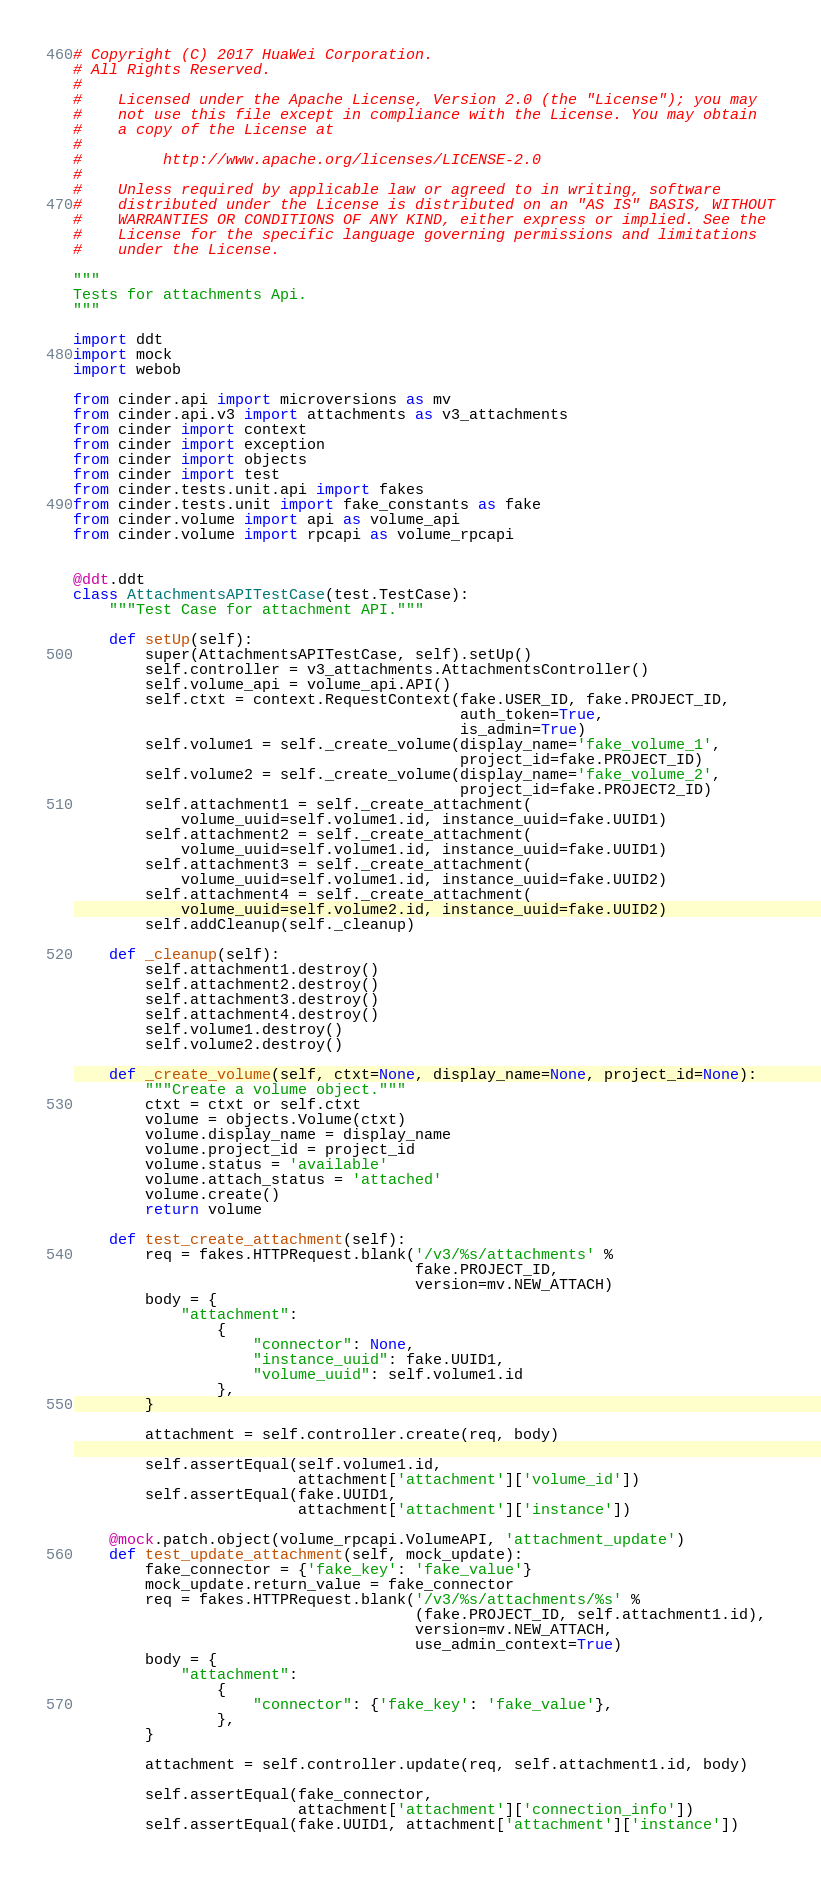<code> <loc_0><loc_0><loc_500><loc_500><_Python_># Copyright (C) 2017 HuaWei Corporation.
# All Rights Reserved.
#
#    Licensed under the Apache License, Version 2.0 (the "License"); you may
#    not use this file except in compliance with the License. You may obtain
#    a copy of the License at
#
#         http://www.apache.org/licenses/LICENSE-2.0
#
#    Unless required by applicable law or agreed to in writing, software
#    distributed under the License is distributed on an "AS IS" BASIS, WITHOUT
#    WARRANTIES OR CONDITIONS OF ANY KIND, either express or implied. See the
#    License for the specific language governing permissions and limitations
#    under the License.

"""
Tests for attachments Api.
"""

import ddt
import mock
import webob

from cinder.api import microversions as mv
from cinder.api.v3 import attachments as v3_attachments
from cinder import context
from cinder import exception
from cinder import objects
from cinder import test
from cinder.tests.unit.api import fakes
from cinder.tests.unit import fake_constants as fake
from cinder.volume import api as volume_api
from cinder.volume import rpcapi as volume_rpcapi


@ddt.ddt
class AttachmentsAPITestCase(test.TestCase):
    """Test Case for attachment API."""

    def setUp(self):
        super(AttachmentsAPITestCase, self).setUp()
        self.controller = v3_attachments.AttachmentsController()
        self.volume_api = volume_api.API()
        self.ctxt = context.RequestContext(fake.USER_ID, fake.PROJECT_ID,
                                           auth_token=True,
                                           is_admin=True)
        self.volume1 = self._create_volume(display_name='fake_volume_1',
                                           project_id=fake.PROJECT_ID)
        self.volume2 = self._create_volume(display_name='fake_volume_2',
                                           project_id=fake.PROJECT2_ID)
        self.attachment1 = self._create_attachment(
            volume_uuid=self.volume1.id, instance_uuid=fake.UUID1)
        self.attachment2 = self._create_attachment(
            volume_uuid=self.volume1.id, instance_uuid=fake.UUID1)
        self.attachment3 = self._create_attachment(
            volume_uuid=self.volume1.id, instance_uuid=fake.UUID2)
        self.attachment4 = self._create_attachment(
            volume_uuid=self.volume2.id, instance_uuid=fake.UUID2)
        self.addCleanup(self._cleanup)

    def _cleanup(self):
        self.attachment1.destroy()
        self.attachment2.destroy()
        self.attachment3.destroy()
        self.attachment4.destroy()
        self.volume1.destroy()
        self.volume2.destroy()

    def _create_volume(self, ctxt=None, display_name=None, project_id=None):
        """Create a volume object."""
        ctxt = ctxt or self.ctxt
        volume = objects.Volume(ctxt)
        volume.display_name = display_name
        volume.project_id = project_id
        volume.status = 'available'
        volume.attach_status = 'attached'
        volume.create()
        return volume

    def test_create_attachment(self):
        req = fakes.HTTPRequest.blank('/v3/%s/attachments' %
                                      fake.PROJECT_ID,
                                      version=mv.NEW_ATTACH)
        body = {
            "attachment":
                {
                    "connector": None,
                    "instance_uuid": fake.UUID1,
                    "volume_uuid": self.volume1.id
                },
        }

        attachment = self.controller.create(req, body)

        self.assertEqual(self.volume1.id,
                         attachment['attachment']['volume_id'])
        self.assertEqual(fake.UUID1,
                         attachment['attachment']['instance'])

    @mock.patch.object(volume_rpcapi.VolumeAPI, 'attachment_update')
    def test_update_attachment(self, mock_update):
        fake_connector = {'fake_key': 'fake_value'}
        mock_update.return_value = fake_connector
        req = fakes.HTTPRequest.blank('/v3/%s/attachments/%s' %
                                      (fake.PROJECT_ID, self.attachment1.id),
                                      version=mv.NEW_ATTACH,
                                      use_admin_context=True)
        body = {
            "attachment":
                {
                    "connector": {'fake_key': 'fake_value'},
                },
        }

        attachment = self.controller.update(req, self.attachment1.id, body)

        self.assertEqual(fake_connector,
                         attachment['attachment']['connection_info'])
        self.assertEqual(fake.UUID1, attachment['attachment']['instance'])
</code> 